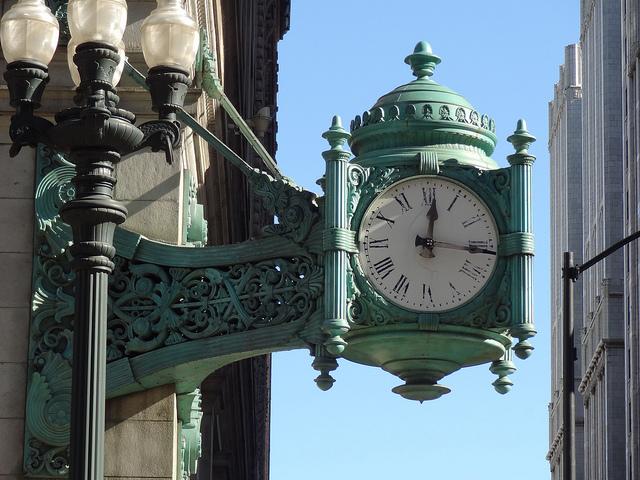What is the condition of the sky?
Answer briefly. Clear. What is the clock made of?
Quick response, please. Metal. What color is the clock?
Answer briefly. Green. What time is it?
Concise answer only. 12:16. 